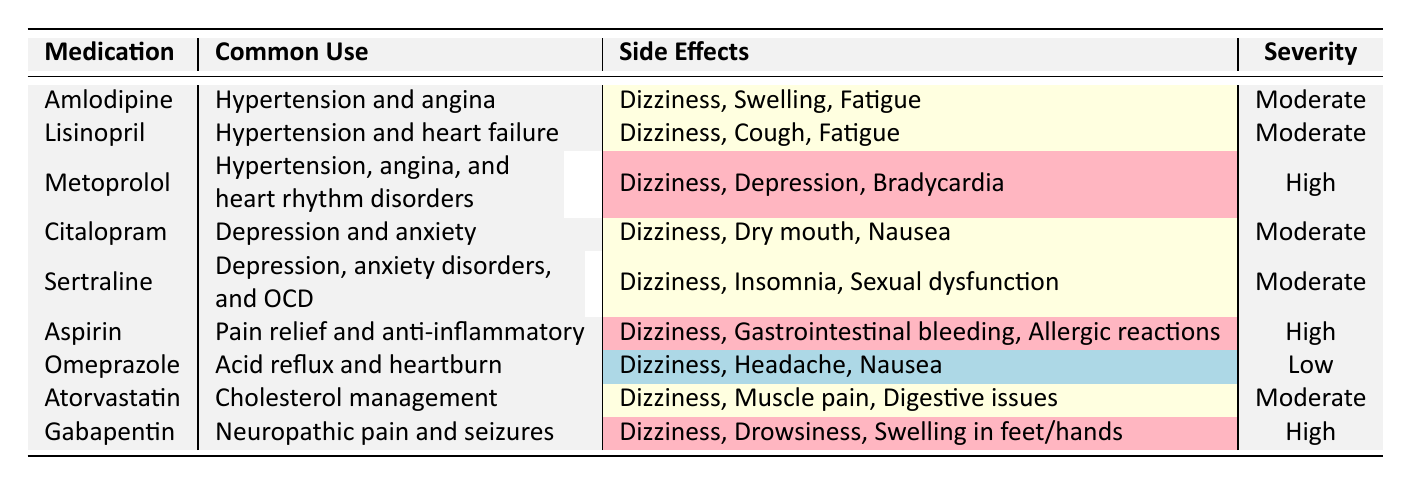What is the common use of Gabapentin? Gabapentin is listed as used for neuropathic pain and seizures in the table.
Answer: Neuropathic pain and seizures Which medication has the highest severity of dizziness as a side effect? The table highlights Metoprolol, Aspirin, and Gabapentin with high severity for dizziness. Since they all have high severity, we focus on the fact that they share the same severity but Metoprolol is the first one listed.
Answer: Metoprolol, Aspirin, and Gabapentin How many medications have dizziness listed as a side effect? By counting the occurrences of "Dizziness" in the side effects, we see it appears in 7 out of 9 medications.
Answer: 7 Is Omeprazole considered to have a high severity for its side effects? The table indicates that Omeprazole has a severity rating of low for dizziness compared to other medications, indicating it does not possess high severity.
Answer: No What are the common uses of medications that have "High" severity for dizziness? The medications with high severity for dizziness are Metoprolol, Aspirin, and Gabapentin. Their common uses are hypertension, pain relief/anti-inflammatory, and neuropathic pain/seizures, respectively.
Answer: Hypertension, pain relief/anti-inflammatory, and neuropathic pain/seizures Which medication, used for cholesterol management, includes dizziness as a side effect? Atorvastatin is identified in the table as the medication for cholesterol management with dizziness as one of its side effects.
Answer: Atorvastatin Among the medications listed, which one is used for depression and has dizziness as a side effect? Both Citalopram and Sertraline are used for depression and anxiety as indicated in the common use column, and both list dizziness as a side effect.
Answer: Citalopram and Sertraline What side effect is common across all medications listed in the table? By reviewing the side effects for each medication, "Dizziness" is consistently listed across most medications, indicating it's a common side effect.
Answer: Dizziness 